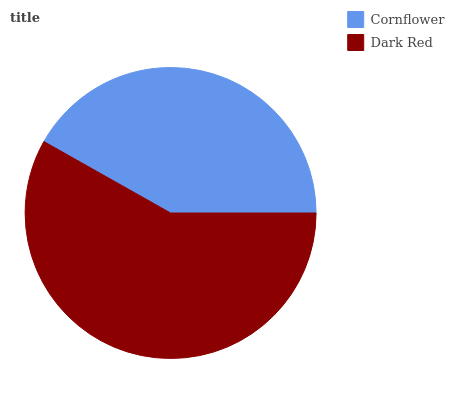Is Cornflower the minimum?
Answer yes or no. Yes. Is Dark Red the maximum?
Answer yes or no. Yes. Is Dark Red the minimum?
Answer yes or no. No. Is Dark Red greater than Cornflower?
Answer yes or no. Yes. Is Cornflower less than Dark Red?
Answer yes or no. Yes. Is Cornflower greater than Dark Red?
Answer yes or no. No. Is Dark Red less than Cornflower?
Answer yes or no. No. Is Dark Red the high median?
Answer yes or no. Yes. Is Cornflower the low median?
Answer yes or no. Yes. Is Cornflower the high median?
Answer yes or no. No. Is Dark Red the low median?
Answer yes or no. No. 